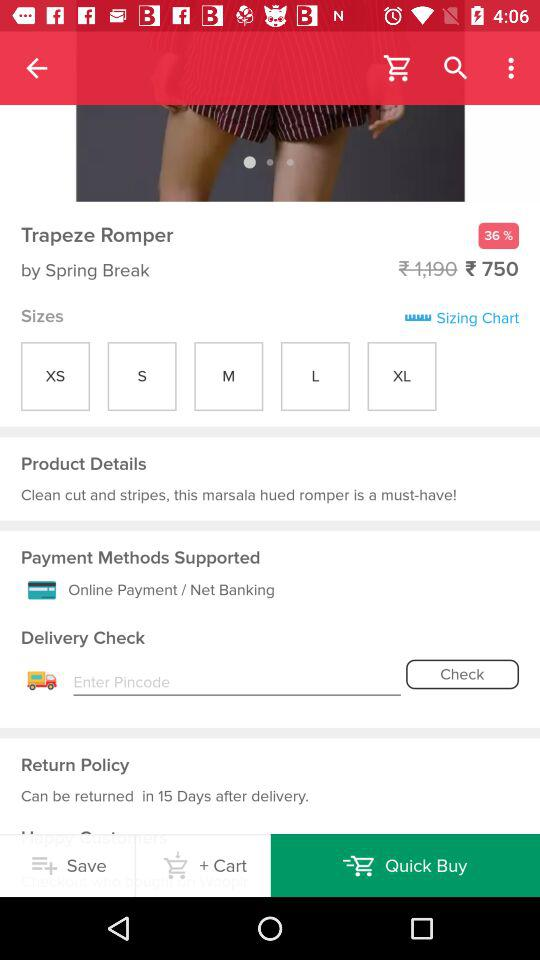How many days do I have to return the product? You can return the product in 15 days after delivery. 